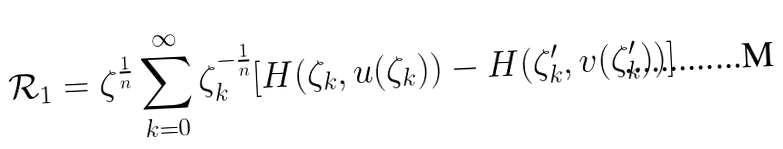Convert formula to latex. <formula><loc_0><loc_0><loc_500><loc_500>\mathcal { R } _ { 1 } = \zeta ^ { \frac { 1 } { n } } \sum _ { k = 0 } ^ { \infty } \zeta _ { k } ^ { - \frac { 1 } { n } } [ H ( \zeta _ { k } , u ( \zeta _ { k } ) ) - H ( \zeta ^ { \prime } _ { k } , v ( \zeta ^ { \prime } _ { k } ) ) ]</formula> 